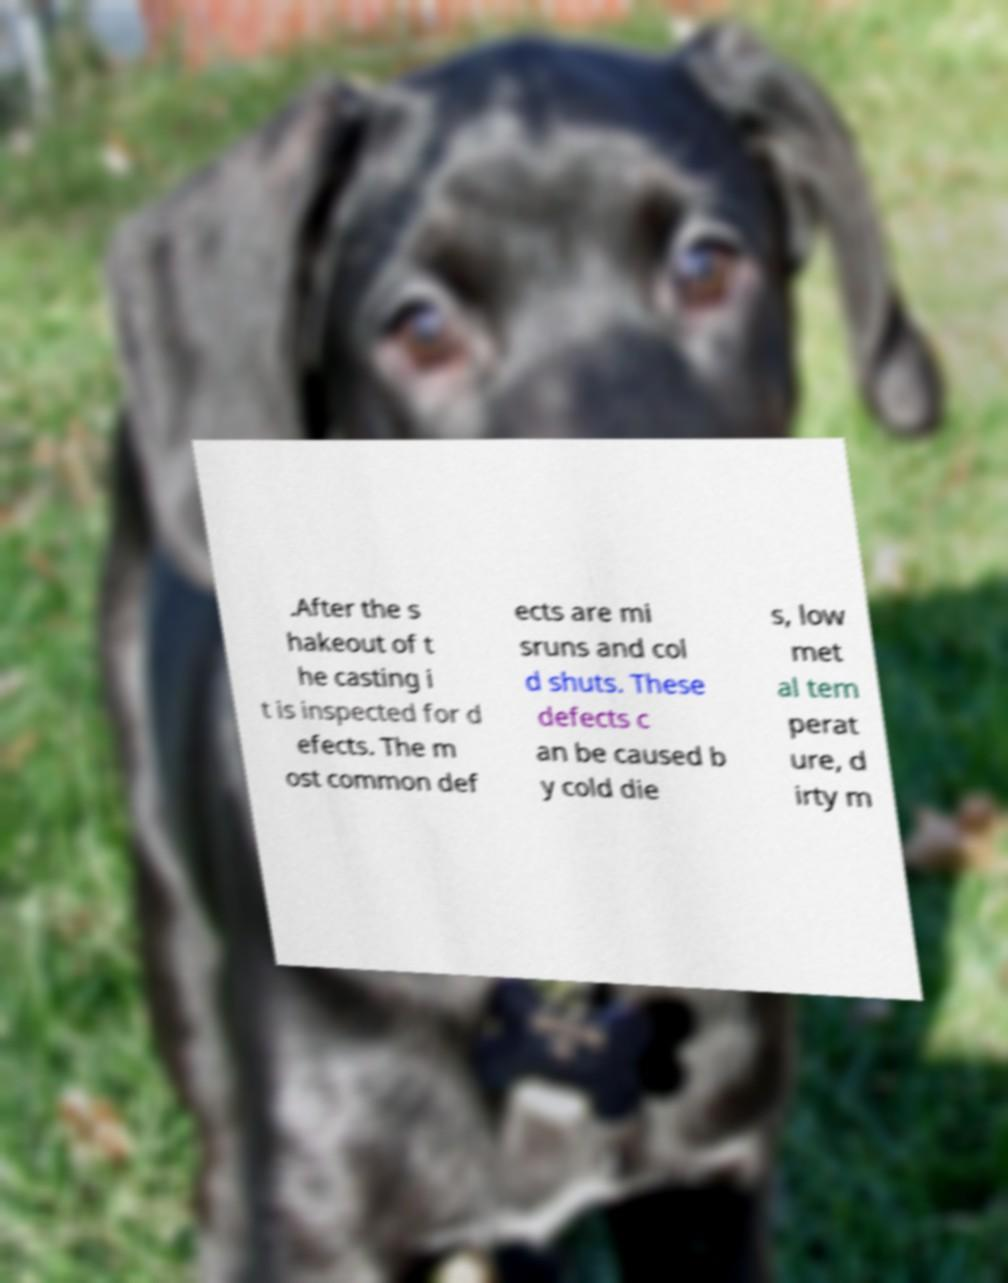Can you accurately transcribe the text from the provided image for me? .After the s hakeout of t he casting i t is inspected for d efects. The m ost common def ects are mi sruns and col d shuts. These defects c an be caused b y cold die s, low met al tem perat ure, d irty m 